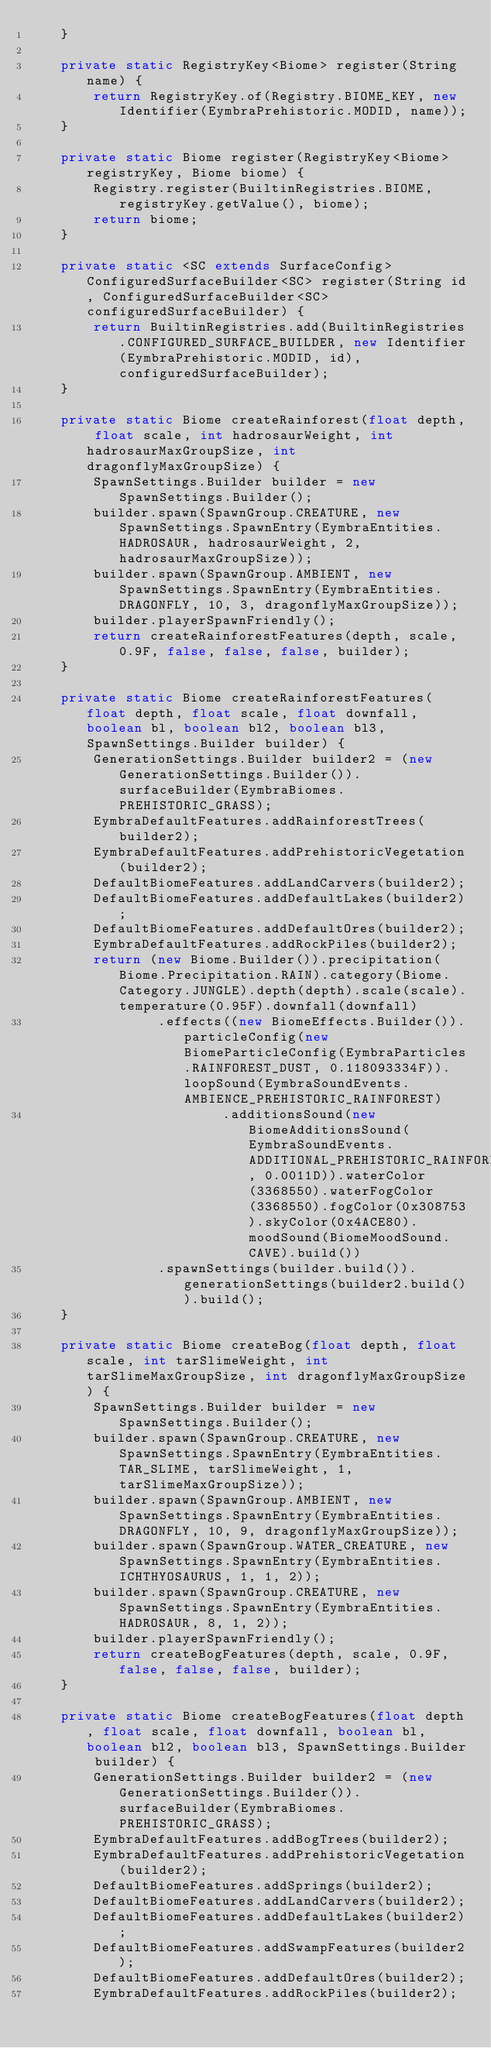<code> <loc_0><loc_0><loc_500><loc_500><_Java_>	}

	private static RegistryKey<Biome> register(String name) {
		return RegistryKey.of(Registry.BIOME_KEY, new Identifier(EymbraPrehistoric.MODID, name));
	}

	private static Biome register(RegistryKey<Biome> registryKey, Biome biome) {
		Registry.register(BuiltinRegistries.BIOME, registryKey.getValue(), biome);
		return biome;
	}

	private static <SC extends SurfaceConfig> ConfiguredSurfaceBuilder<SC> register(String id, ConfiguredSurfaceBuilder<SC> configuredSurfaceBuilder) {
		return BuiltinRegistries.add(BuiltinRegistries.CONFIGURED_SURFACE_BUILDER, new Identifier(EymbraPrehistoric.MODID, id), configuredSurfaceBuilder);
	}

	private static Biome createRainforest(float depth, float scale, int hadrosaurWeight, int hadrosaurMaxGroupSize, int dragonflyMaxGroupSize) {
		SpawnSettings.Builder builder = new SpawnSettings.Builder();
		builder.spawn(SpawnGroup.CREATURE, new SpawnSettings.SpawnEntry(EymbraEntities.HADROSAUR, hadrosaurWeight, 2, hadrosaurMaxGroupSize));
		builder.spawn(SpawnGroup.AMBIENT, new SpawnSettings.SpawnEntry(EymbraEntities.DRAGONFLY, 10, 3, dragonflyMaxGroupSize));
		builder.playerSpawnFriendly();
		return createRainforestFeatures(depth, scale, 0.9F, false, false, false, builder);
	}

	private static Biome createRainforestFeatures(float depth, float scale, float downfall, boolean bl, boolean bl2, boolean bl3, SpawnSettings.Builder builder) {
		GenerationSettings.Builder builder2 = (new GenerationSettings.Builder()).surfaceBuilder(EymbraBiomes.PREHISTORIC_GRASS);
		EymbraDefaultFeatures.addRainforestTrees(builder2);
		EymbraDefaultFeatures.addPrehistoricVegetation(builder2);
		DefaultBiomeFeatures.addLandCarvers(builder2);
		DefaultBiomeFeatures.addDefaultLakes(builder2);
		DefaultBiomeFeatures.addDefaultOres(builder2);
		EymbraDefaultFeatures.addRockPiles(builder2);
		return (new Biome.Builder()).precipitation(Biome.Precipitation.RAIN).category(Biome.Category.JUNGLE).depth(depth).scale(scale).temperature(0.95F).downfall(downfall)
				.effects((new BiomeEffects.Builder()).particleConfig(new BiomeParticleConfig(EymbraParticles.RAINFOREST_DUST, 0.118093334F)).loopSound(EymbraSoundEvents.AMBIENCE_PREHISTORIC_RAINFOREST)
						.additionsSound(new BiomeAdditionsSound(EymbraSoundEvents.ADDITIONAL_PREHISTORIC_RAINFOREST, 0.0011D)).waterColor(3368550).waterFogColor(3368550).fogColor(0x308753).skyColor(0x4ACE80).moodSound(BiomeMoodSound.CAVE).build())
				.spawnSettings(builder.build()).generationSettings(builder2.build()).build();
	}

	private static Biome createBog(float depth, float scale, int tarSlimeWeight, int tarSlimeMaxGroupSize, int dragonflyMaxGroupSize) {
		SpawnSettings.Builder builder = new SpawnSettings.Builder();
		builder.spawn(SpawnGroup.CREATURE, new SpawnSettings.SpawnEntry(EymbraEntities.TAR_SLIME, tarSlimeWeight, 1, tarSlimeMaxGroupSize));
		builder.spawn(SpawnGroup.AMBIENT, new SpawnSettings.SpawnEntry(EymbraEntities.DRAGONFLY, 10, 9, dragonflyMaxGroupSize));
		builder.spawn(SpawnGroup.WATER_CREATURE, new SpawnSettings.SpawnEntry(EymbraEntities.ICHTHYOSAURUS, 1, 1, 2));
		builder.spawn(SpawnGroup.CREATURE, new SpawnSettings.SpawnEntry(EymbraEntities.HADROSAUR, 8, 1, 2));
		builder.playerSpawnFriendly();
		return createBogFeatures(depth, scale, 0.9F, false, false, false, builder);
	}

	private static Biome createBogFeatures(float depth, float scale, float downfall, boolean bl, boolean bl2, boolean bl3, SpawnSettings.Builder builder) {
		GenerationSettings.Builder builder2 = (new GenerationSettings.Builder()).surfaceBuilder(EymbraBiomes.PREHISTORIC_GRASS);
		EymbraDefaultFeatures.addBogTrees(builder2);
		EymbraDefaultFeatures.addPrehistoricVegetation(builder2);
		DefaultBiomeFeatures.addSprings(builder2);
		DefaultBiomeFeatures.addLandCarvers(builder2);
		DefaultBiomeFeatures.addDefaultLakes(builder2);
		DefaultBiomeFeatures.addSwampFeatures(builder2);
		DefaultBiomeFeatures.addDefaultOres(builder2);
		EymbraDefaultFeatures.addRockPiles(builder2);
</code> 